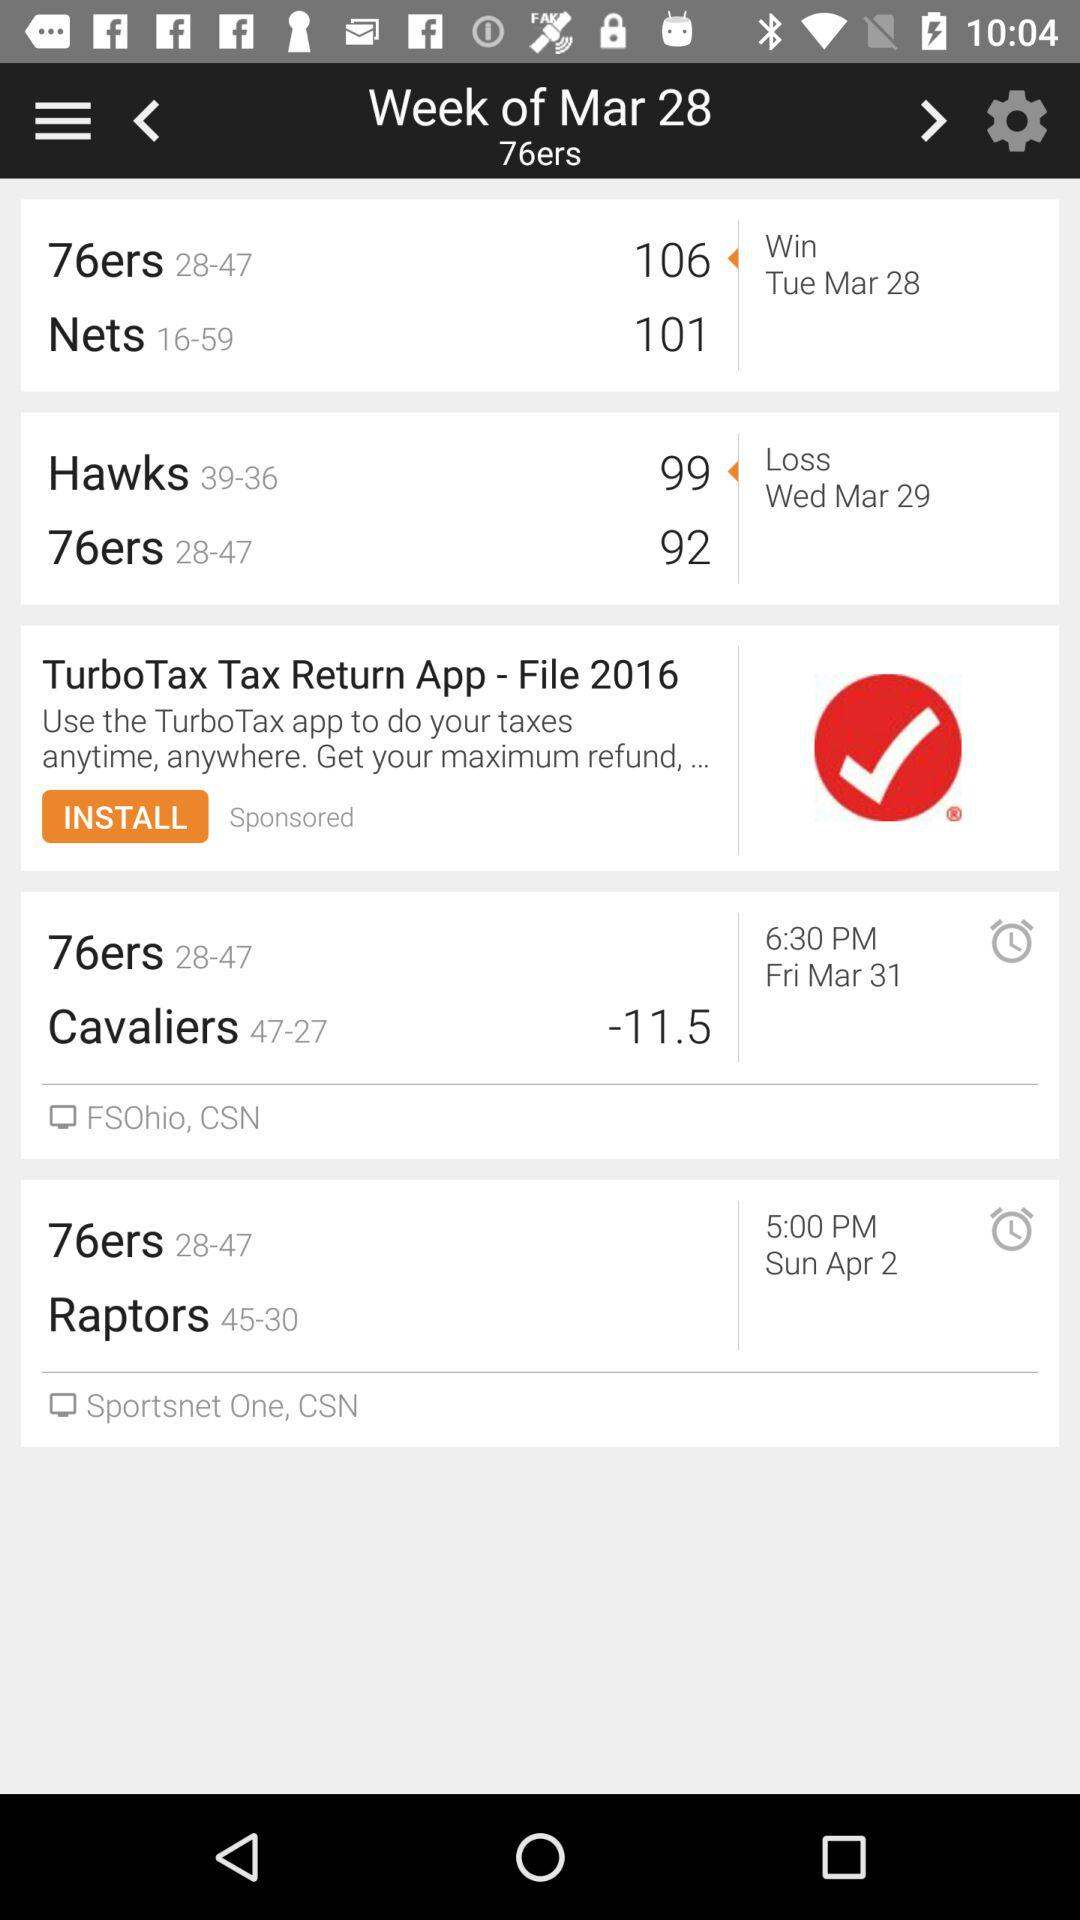What was the score of the "76ers" on March 29? The score was 92. 